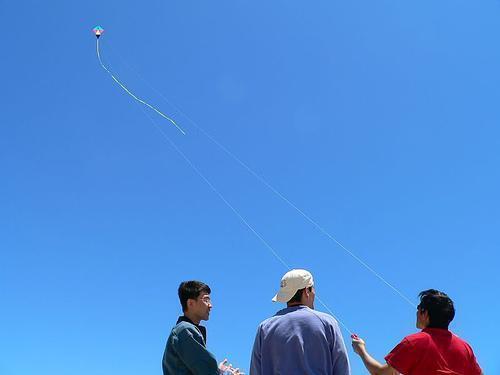Which color shirt does the person flying the kite wear?
Select the accurate answer and provide explanation: 'Answer: answer
Rationale: rationale.'
Options: Green, lavender, red, teal. Answer: red.
Rationale: The man in red is holding the kite string. 